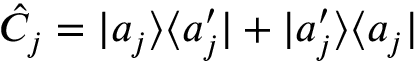Convert formula to latex. <formula><loc_0><loc_0><loc_500><loc_500>\hat { C } _ { j } = | a _ { j } \rangle \langle a _ { j } ^ { \prime } | + | a _ { j } ^ { \prime } \rangle \langle a _ { j } |</formula> 